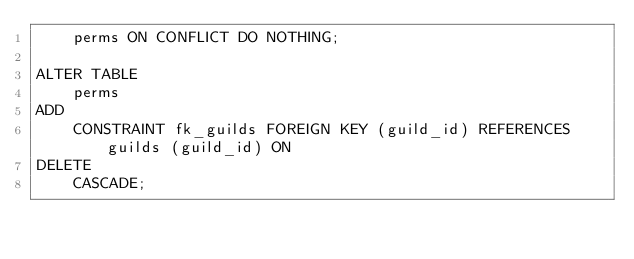Convert code to text. <code><loc_0><loc_0><loc_500><loc_500><_SQL_>    perms ON CONFLICT DO NOTHING;

ALTER TABLE
    perms
ADD
    CONSTRAINT fk_guilds FOREIGN KEY (guild_id) REFERENCES guilds (guild_id) ON
DELETE
    CASCADE;</code> 